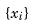<formula> <loc_0><loc_0><loc_500><loc_500>\{ x _ { i } \}</formula> 